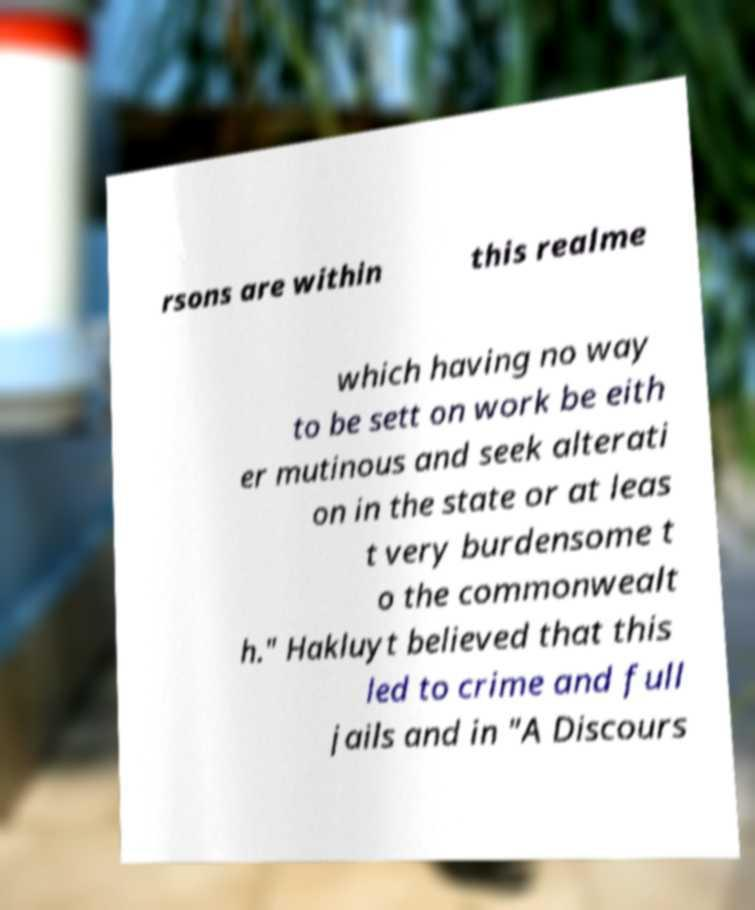There's text embedded in this image that I need extracted. Can you transcribe it verbatim? rsons are within this realme which having no way to be sett on work be eith er mutinous and seek alterati on in the state or at leas t very burdensome t o the commonwealt h." Hakluyt believed that this led to crime and full jails and in "A Discours 